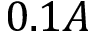Convert formula to latex. <formula><loc_0><loc_0><loc_500><loc_500>0 . 1 A</formula> 